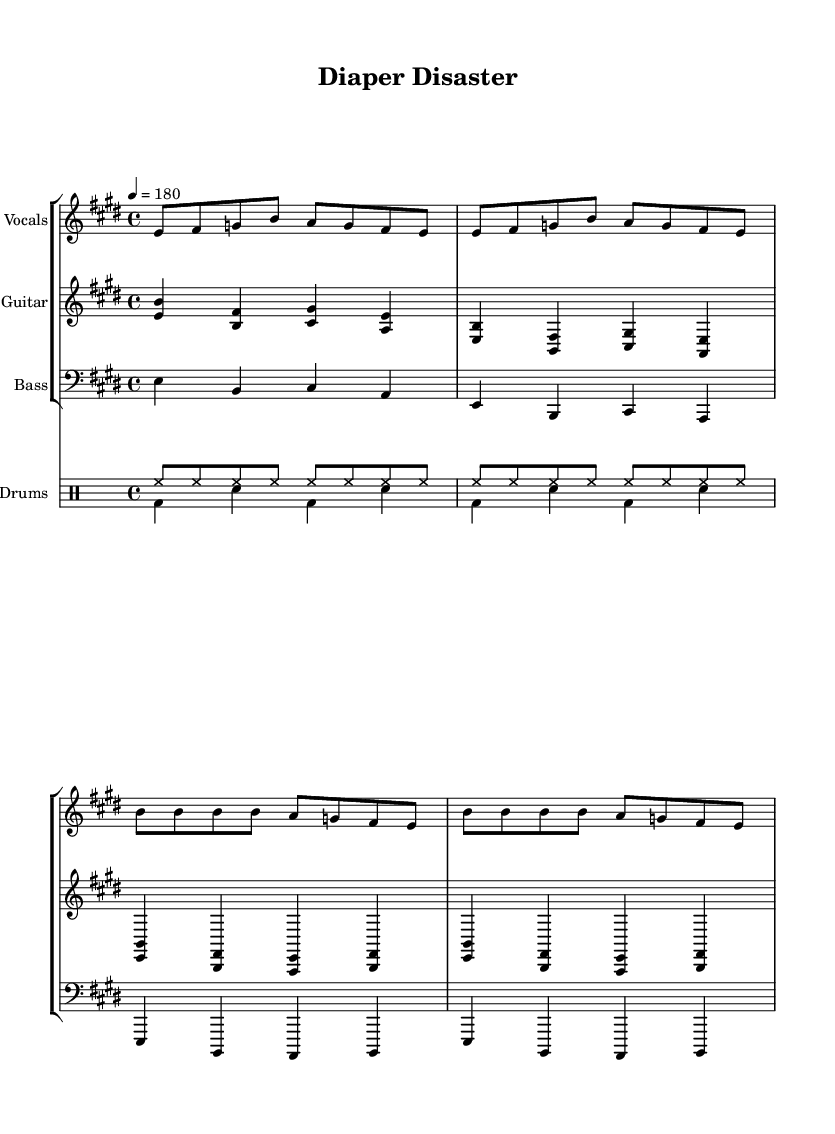What is the key signature of this music? The key signature is E major, which has four sharps: F#, C#, G#, and D#.
Answer: E major What is the time signature? The time signature is 4/4, meaning there are four beats in a measure.
Answer: 4/4 What is the tempo indication? The tempo indication is quarter note equals 180, which indicates a fast pace.
Answer: 180 How many verses are there in the lullaby section? There are two verses in the lullaby section, as indicated by the repeated vocal lines.
Answer: 2 What type of music is this piece classified as? This piece is classified as punk music, characterized by its fast tempo, power chords, and aggressive rhythm patterns.
Answer: Punk Why is there a use of power chords in the electric guitar part? Power chords are typically used in punk music for their strength and simplicity, allowing for a driving sound that matches the genre's energetic vibe.
Answer: Strength and simplicity What lyrics express the theme of chaos in early parenthood? "Diaper disaster, midnight feeds, chaos reigns, but love succeeds" express the chaos and love of early parenthood.
Answer: Diaper disaster, midnight feeds, chaos reigns, but love succeeds 